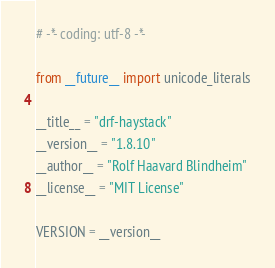<code> <loc_0><loc_0><loc_500><loc_500><_Python_># -*- coding: utf-8 -*-

from __future__ import unicode_literals

__title__ = "drf-haystack"
__version__ = "1.8.10"
__author__ = "Rolf Haavard Blindheim"
__license__ = "MIT License"

VERSION = __version__
</code> 